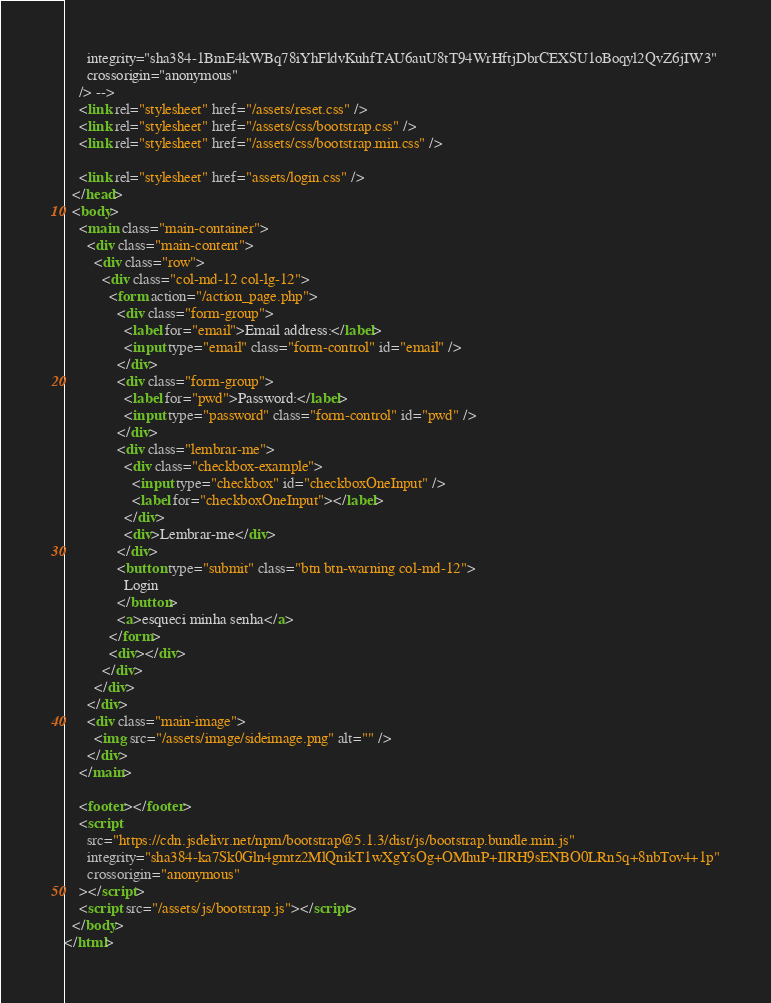<code> <loc_0><loc_0><loc_500><loc_500><_HTML_>      integrity="sha384-1BmE4kWBq78iYhFldvKuhfTAU6auU8tT94WrHftjDbrCEXSU1oBoqyl2QvZ6jIW3"
      crossorigin="anonymous"
    /> -->
    <link rel="stylesheet" href="/assets/reset.css" />
    <link rel="stylesheet" href="/assets/css/bootstrap.css" />
    <link rel="stylesheet" href="/assets/css/bootstrap.min.css" />

    <link rel="stylesheet" href="assets/login.css" />
  </head>
  <body>
    <main class="main-container">
      <div class="main-content">
        <div class="row">
          <div class="col-md-12 col-lg-12">
            <form action="/action_page.php">
              <div class="form-group">
                <label for="email">Email address:</label>
                <input type="email" class="form-control" id="email" />
              </div>
              <div class="form-group">
                <label for="pwd">Password:</label>
                <input type="password" class="form-control" id="pwd" />
              </div>
              <div class="lembrar-me">
                <div class="checkbox-example">
                  <input type="checkbox" id="checkboxOneInput" />
                  <label for="checkboxOneInput"></label>
                </div>
                <div>Lembrar-me</div>
              </div>
              <button type="submit" class="btn btn-warning col-md-12">
                Login
              </button>
              <a>esqueci minha senha</a>
            </form>
            <div></div>
          </div>
        </div>
      </div>
      <div class="main-image">
        <img src="/assets/image/sideimage.png" alt="" />
      </div>
    </main>

    <footer></footer>
    <script
      src="https://cdn.jsdelivr.net/npm/bootstrap@5.1.3/dist/js/bootstrap.bundle.min.js"
      integrity="sha384-ka7Sk0Gln4gmtz2MlQnikT1wXgYsOg+OMhuP+IlRH9sENBO0LRn5q+8nbTov4+1p"
      crossorigin="anonymous"
    ></script>
    <script src="/assets/js/bootstrap.js"></script>
  </body>
</html>
</code> 